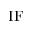Convert formula to latex. <formula><loc_0><loc_0><loc_500><loc_500>I F</formula> 